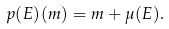Convert formula to latex. <formula><loc_0><loc_0><loc_500><loc_500>p ( E ) ( m ) = m + \mu ( E ) .</formula> 